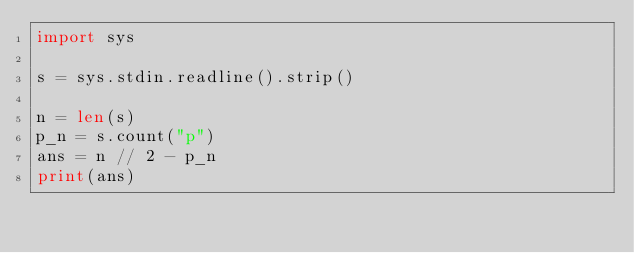Convert code to text. <code><loc_0><loc_0><loc_500><loc_500><_Python_>import sys

s = sys.stdin.readline().strip()

n = len(s)
p_n = s.count("p")
ans = n // 2 - p_n
print(ans)</code> 